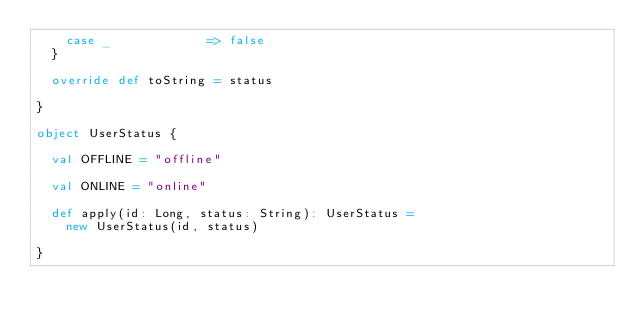<code> <loc_0><loc_0><loc_500><loc_500><_Scala_>    case _             => false
  }

  override def toString = status

}

object UserStatus {

  val OFFLINE = "offline"

  val ONLINE = "online"

  def apply(id: Long, status: String): UserStatus =
    new UserStatus(id, status)

}</code> 